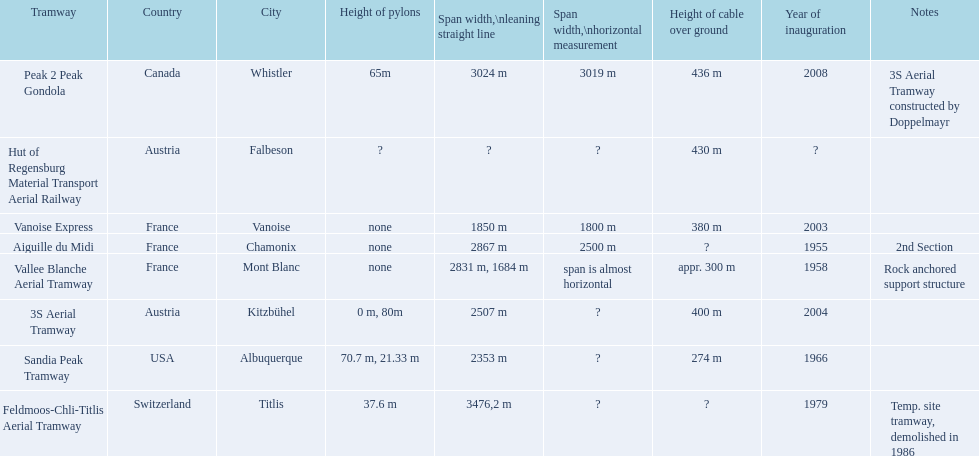When did the inauguration of the aiguille du midi tramway take place? 1955. When was the 3s aerial tramway launched? 2004. Which of the two had its inauguration earlier? Aiguille du Midi. 